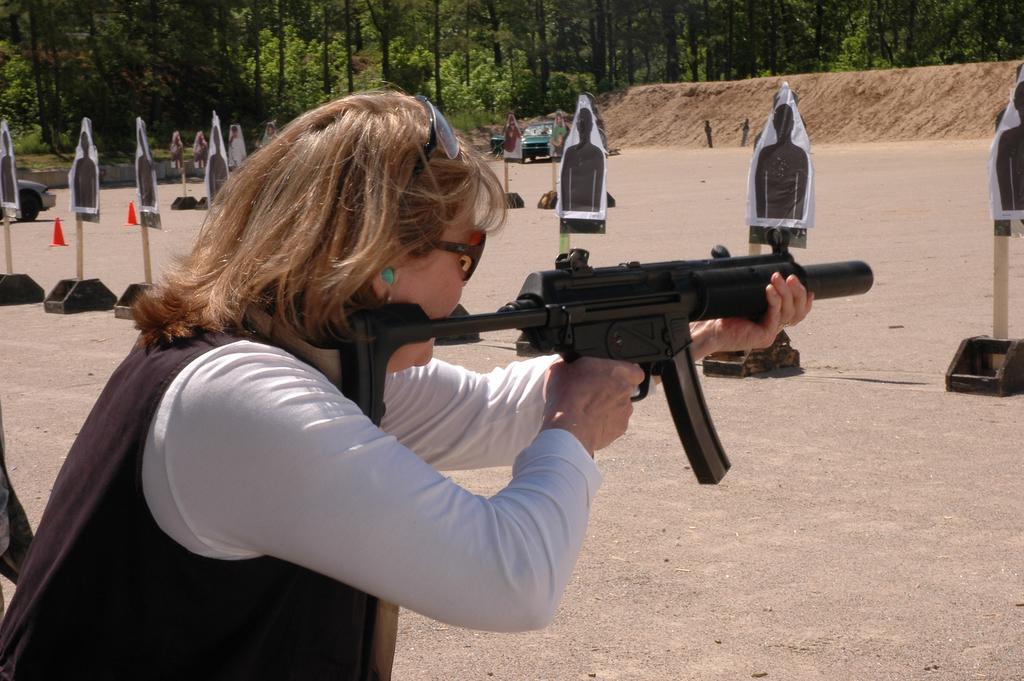Could you give a brief overview of what you see in this image? In this image there is a person holding a gun and shooting the target, there are few targets, cones, few trees, a vehicle and sand. 